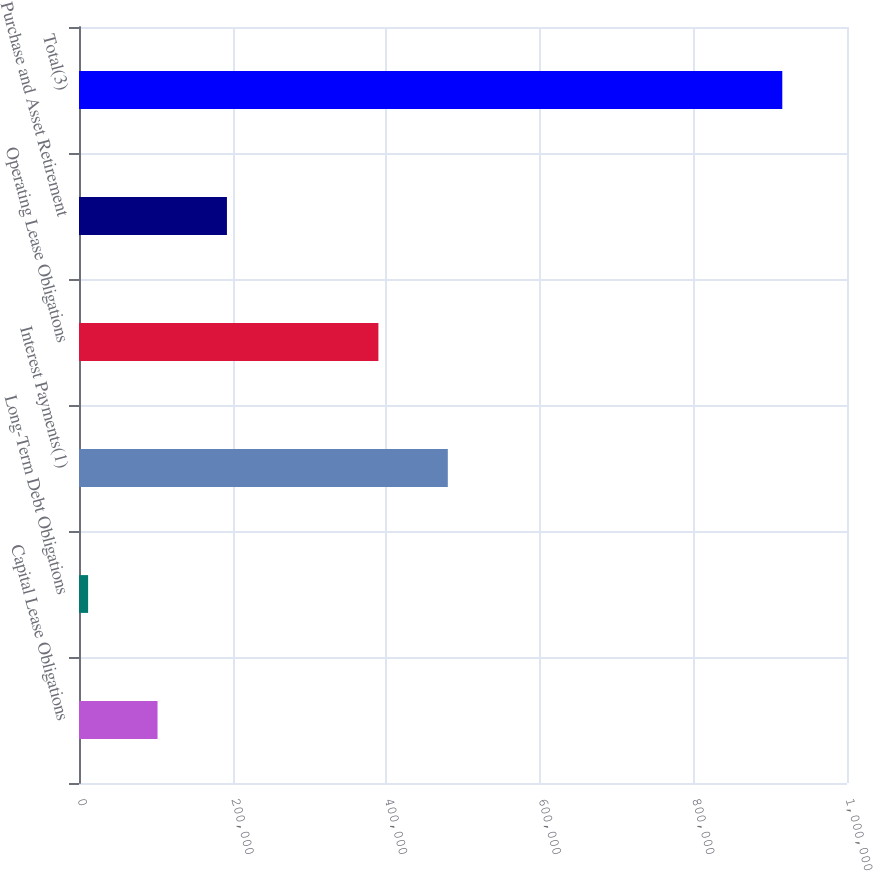Convert chart to OTSL. <chart><loc_0><loc_0><loc_500><loc_500><bar_chart><fcel>Capital Lease Obligations<fcel>Long-Term Debt Obligations<fcel>Interest Payments(1)<fcel>Operating Lease Obligations<fcel>Purchase and Asset Retirement<fcel>Total(3)<nl><fcel>102247<fcel>11858<fcel>480222<fcel>389833<fcel>192636<fcel>915748<nl></chart> 